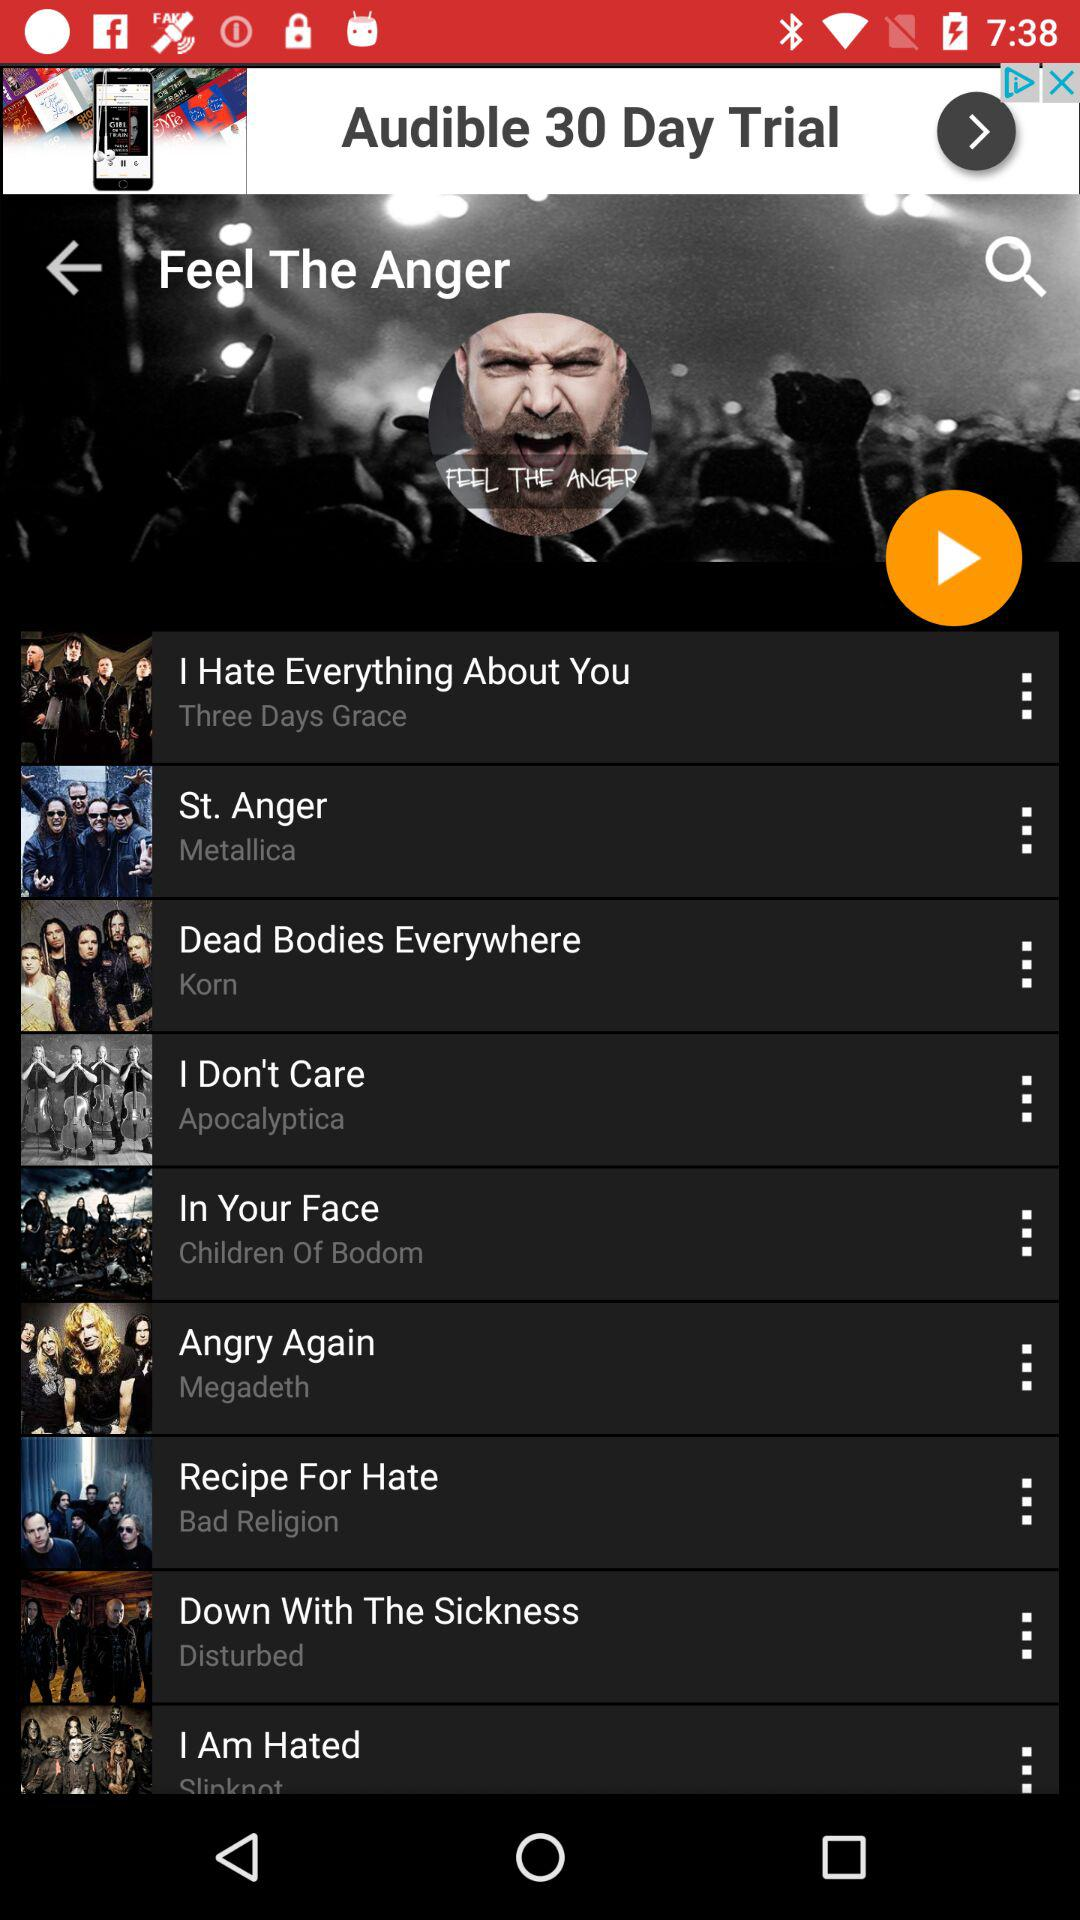What is the name of the song by "Disturbed"? The name of the song by "Disturbed" is "Down With The Sickness". 